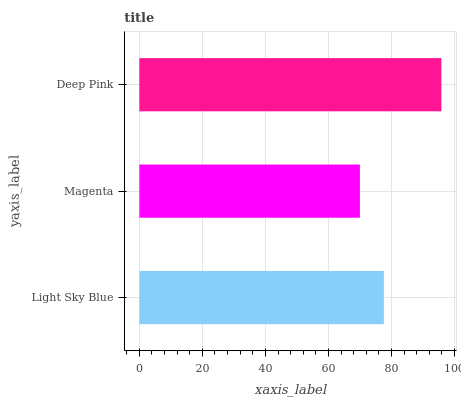Is Magenta the minimum?
Answer yes or no. Yes. Is Deep Pink the maximum?
Answer yes or no. Yes. Is Deep Pink the minimum?
Answer yes or no. No. Is Magenta the maximum?
Answer yes or no. No. Is Deep Pink greater than Magenta?
Answer yes or no. Yes. Is Magenta less than Deep Pink?
Answer yes or no. Yes. Is Magenta greater than Deep Pink?
Answer yes or no. No. Is Deep Pink less than Magenta?
Answer yes or no. No. Is Light Sky Blue the high median?
Answer yes or no. Yes. Is Light Sky Blue the low median?
Answer yes or no. Yes. Is Deep Pink the high median?
Answer yes or no. No. Is Magenta the low median?
Answer yes or no. No. 